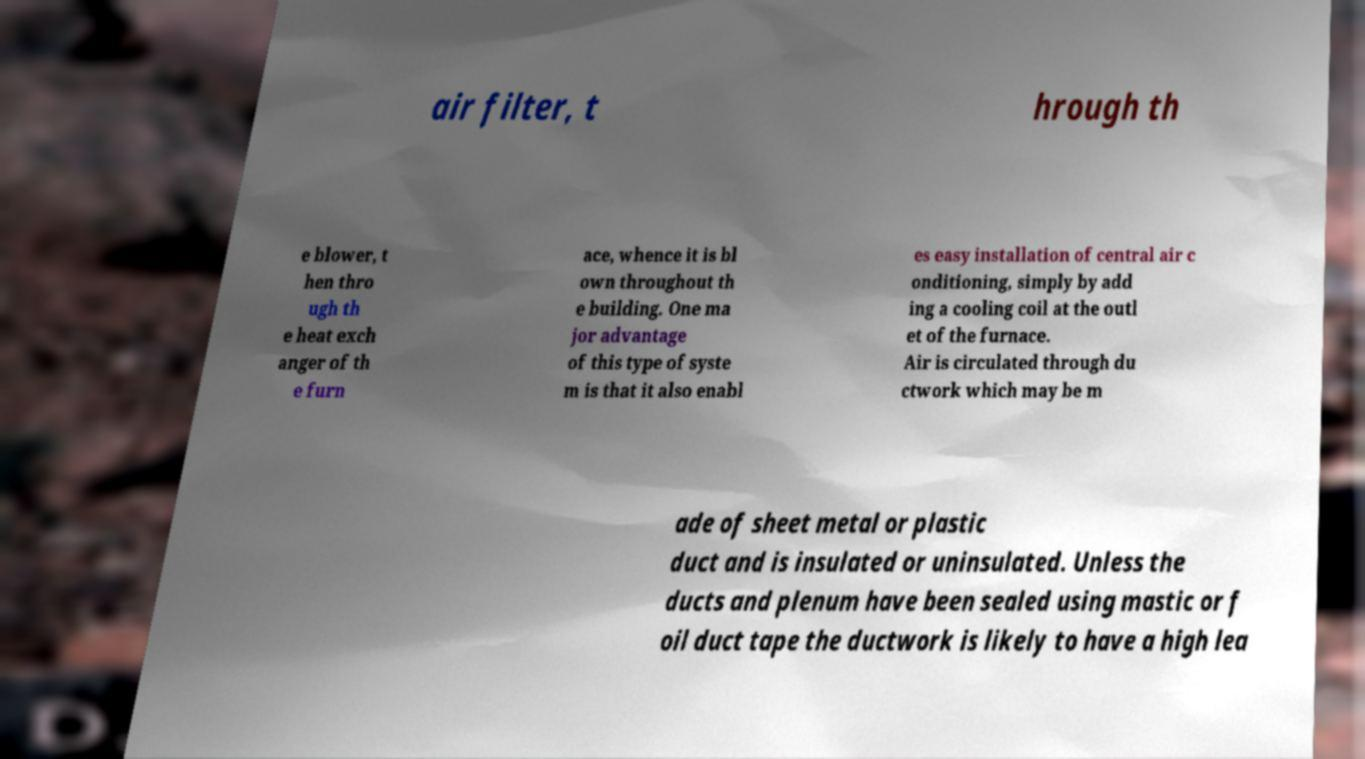There's text embedded in this image that I need extracted. Can you transcribe it verbatim? air filter, t hrough th e blower, t hen thro ugh th e heat exch anger of th e furn ace, whence it is bl own throughout th e building. One ma jor advantage of this type of syste m is that it also enabl es easy installation of central air c onditioning, simply by add ing a cooling coil at the outl et of the furnace. Air is circulated through du ctwork which may be m ade of sheet metal or plastic duct and is insulated or uninsulated. Unless the ducts and plenum have been sealed using mastic or f oil duct tape the ductwork is likely to have a high lea 